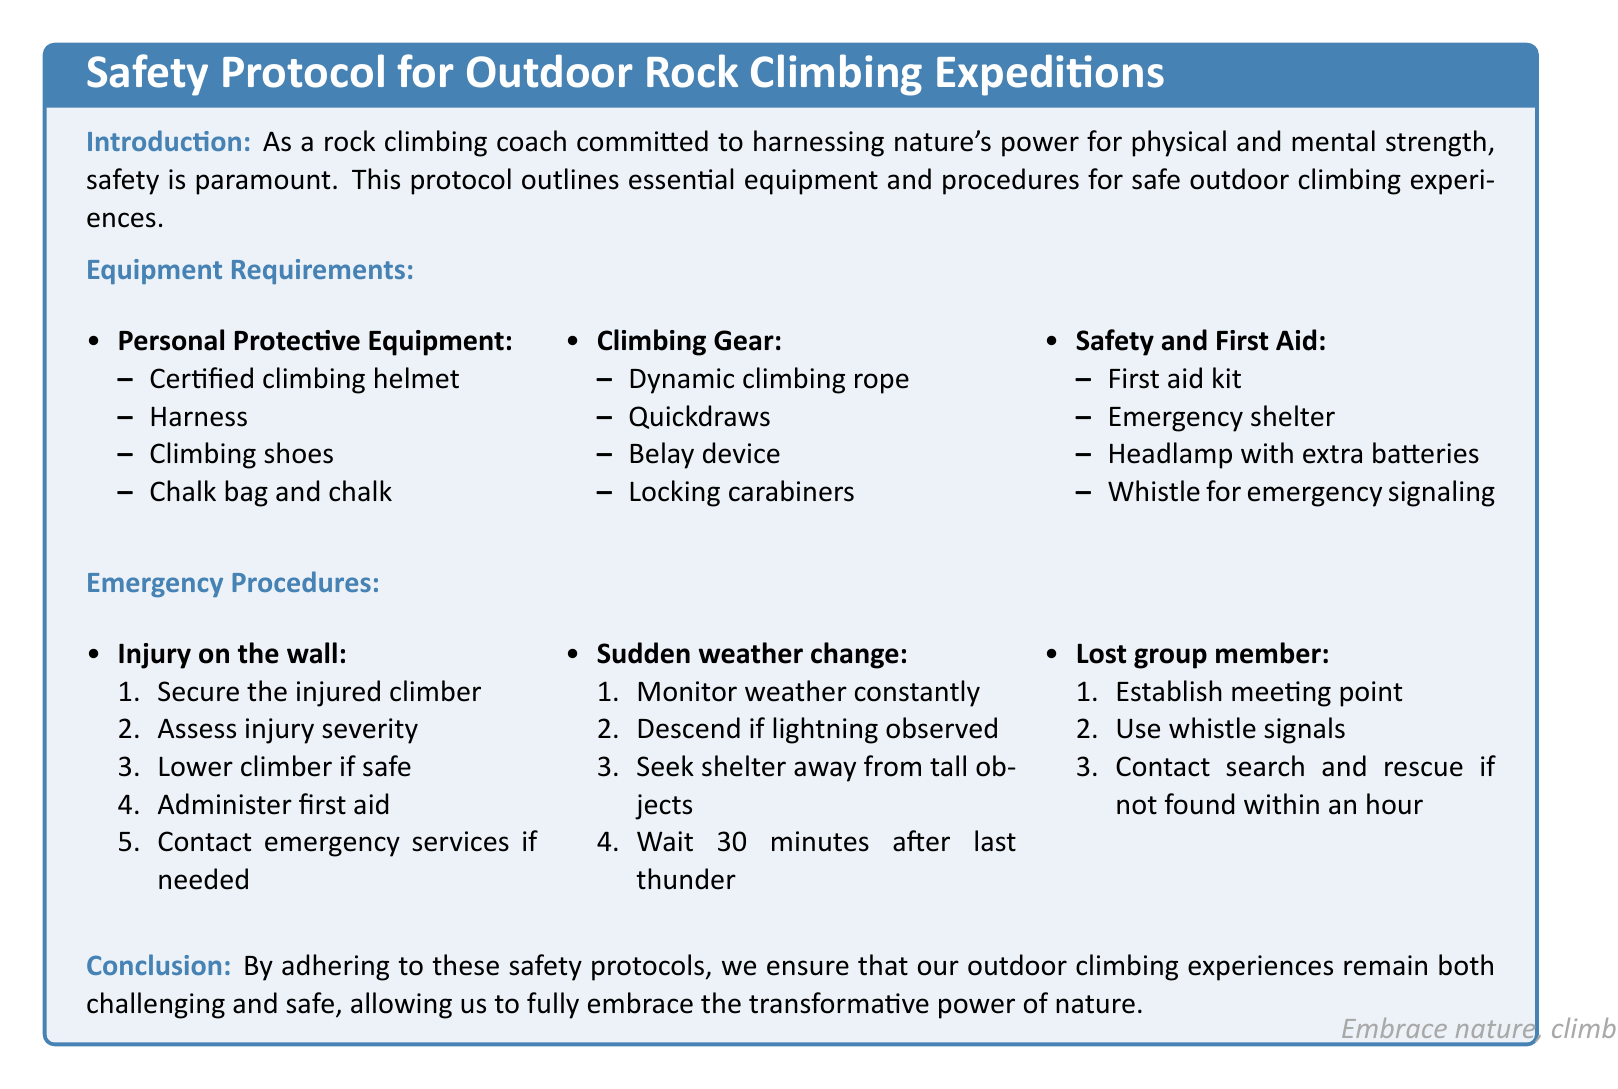What is the primary focus of the document? The primary focus of the document is safety protocols for outdoor rock climbing expeditions.
Answer: safety protocols for outdoor rock climbing expeditions How many personal protective equipment items are listed? There are four items listed under personal protective equipment in the document.
Answer: four What is required for emergency signaling? The document states that a whistle is required for emergency signaling.
Answer: whistle What should be done if there's an injury on the wall? The first step is to secure the injured climber.
Answer: secure the injured climber What should you monitor constantly according to the emergency procedures? The document advises to monitor the weather constantly in case of sudden weather change.
Answer: weather How many items are required for Safety and First Aid? There are four items listed under Safety and First Aid.
Answer: four What is the waiting time after the last thunder? The document specifies a waiting time of 30 minutes after the last thunder.
Answer: 30 minutes What should be established if a group member is lost? The document states that a meeting point should be established if a group member is lost.
Answer: meeting point What does the conclusion suggest about adhering to safety protocols? The conclusion suggests that adhering to safety protocols allows for challenging and safe outdoor climbing experiences.
Answer: challenging and safe outdoor climbing experiences 